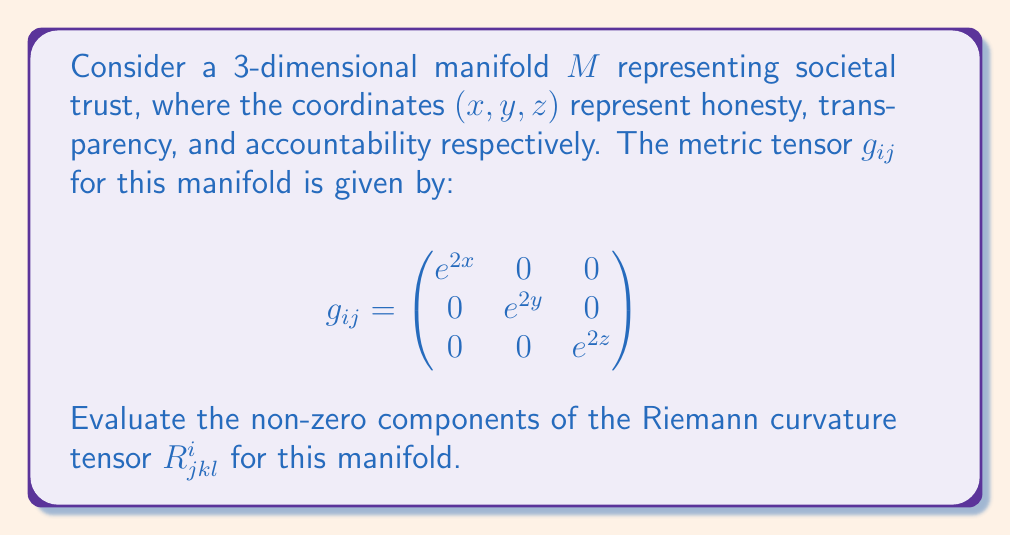Provide a solution to this math problem. To evaluate the Riemann curvature tensor, we'll follow these steps:

1) First, we need to calculate the Christoffel symbols $\Gamma^i_{jk}$ using the formula:

   $$\Gamma^i_{jk} = \frac{1}{2}g^{im}(\partial_j g_{km} + \partial_k g_{jm} - \partial_m g_{jk})$$

2) For our diagonal metric, the non-zero Christoffel symbols are:

   $$\Gamma^i_{ii} = \partial_i g_{ii} / (2g_{ii}) = 1 \quad \text{(no sum on } i)$$

3) Now, we can calculate the Riemann tensor using:

   $$R^i_{jkl} = \partial_k \Gamma^i_{jl} - \partial_l \Gamma^i_{jk} + \Gamma^i_{mk}\Gamma^m_{jl} - \Gamma^i_{ml}\Gamma^m_{jk}$$

4) Due to the symmetries of the Riemann tensor, we only need to calculate $R^i_{jkl}$ where $i < j$ and $k < l$. The non-zero components are:

   $$R^1_{212} = \partial_1 \Gamma^1_{22} - \partial_2 \Gamma^1_{21} + \Gamma^1_{m1}\Gamma^m_{22} - \Gamma^1_{m2}\Gamma^m_{21}$$
   $$= 0 - 0 + \Gamma^1_{11}\Gamma^1_{22} - 0 = 1 \cdot 1 = 1$$

   Similarly,
   $$R^1_{313} = 1$$
   $$R^2_{323} = 1$$

5) The remaining non-zero components can be obtained by the symmetry properties:

   $$R^i_{jkl} = -R^i_{jlk} = -R^j_{ikl} = R^j_{ilk}$$

Thus, the other non-zero components are:
   $$R^2_{121} = R^3_{131} = R^3_{232} = -1$$
Answer: The non-zero components of the Riemann curvature tensor for the given manifold are:

$$R^1_{212} = R^1_{313} = R^2_{323} = 1$$
$$R^2_{121} = R^3_{131} = R^3_{232} = -1$$ 